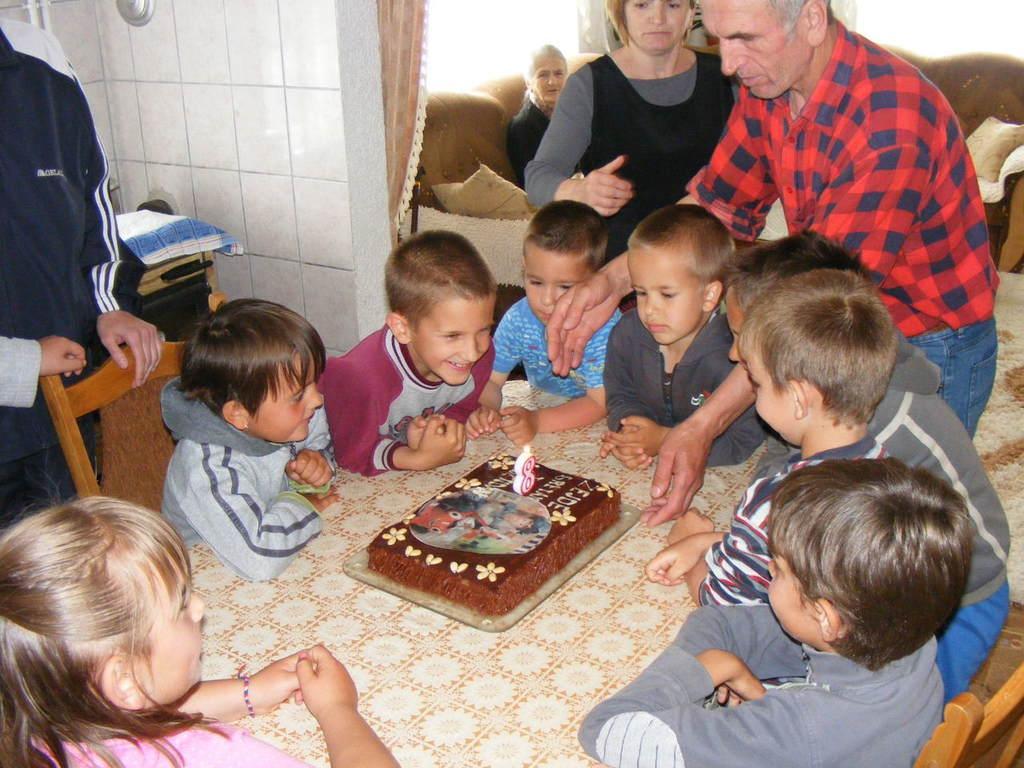How would you summarize this image in a sentence or two? In a picture there are so many children sitting and standing on a table and on the table there is one cake and on that there is one candle and at the right corner two people are standing one person in red shirt and one woman in black dress and behind them there is a one sofa and pillows on that one woman is sitting and coming to the left corner of the picture one person is standing and behind the person there is one table and a cloth on it and a wall is present. 